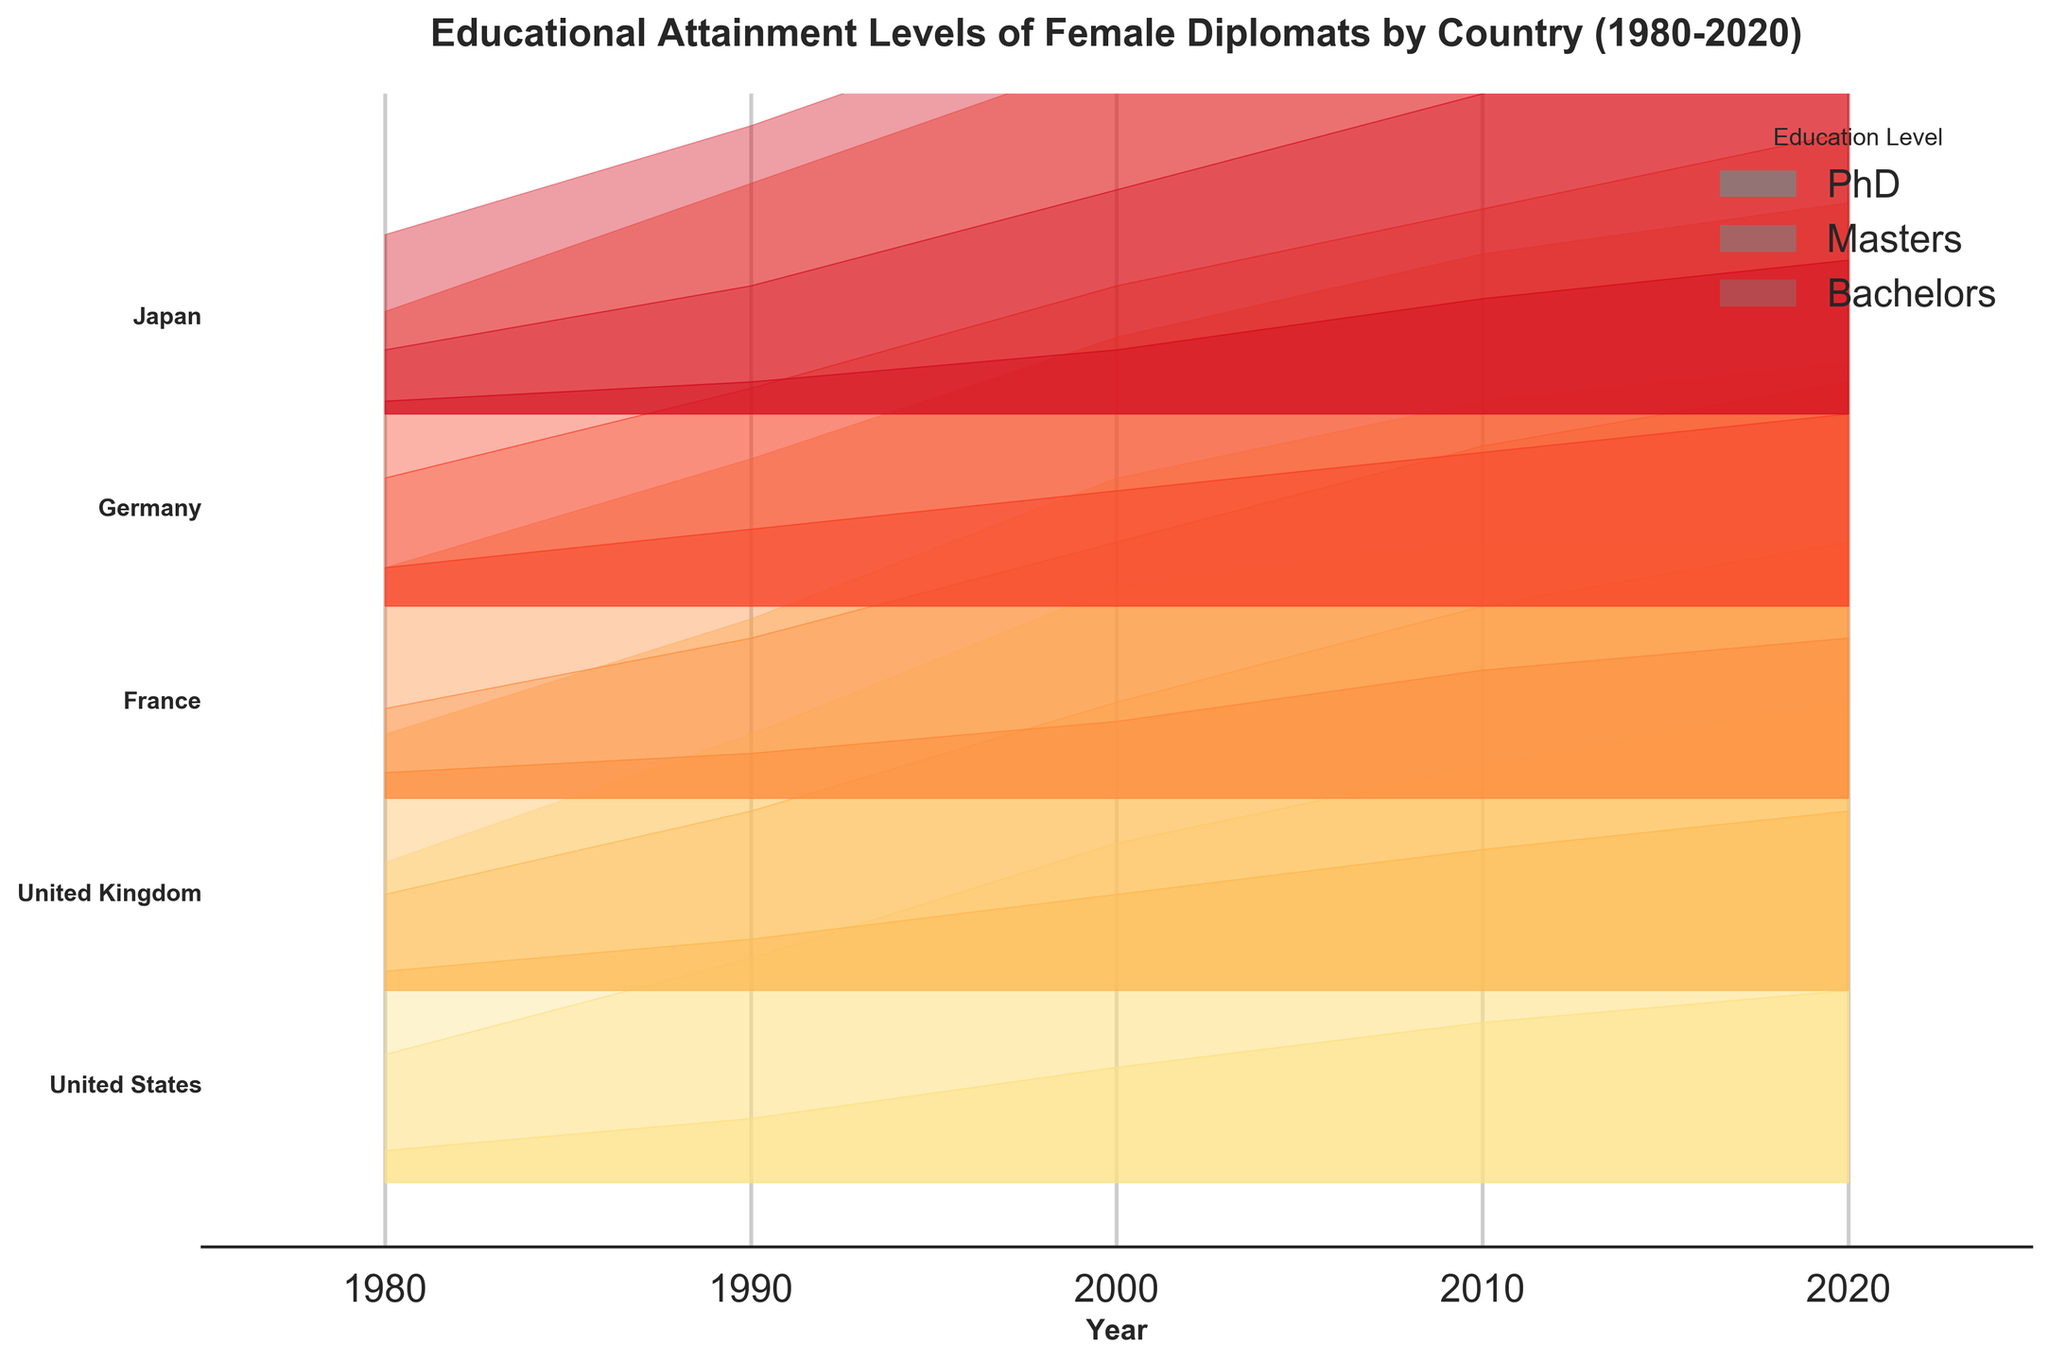Which country had the highest percentage of female diplomats with a PhD in 2020? To find this, look at the highest peak of the PhD area (most opaque gray) for the year 2020 across all countries.
Answer: Germany What is the trend in educational attainment among female diplomats in the United States from 1980 to 2020? Track the changes in the layers (PhD, Masters, Bachelors) over time. Notice that the PhD percentage has increased consistently, while Masters has also shown growth. Bachelors peaked in 2000 and then decreased.
Answer: PhD and Masters increased, Bachelors peaked and then decreased Which country showed the most significant increase in the percentage of female diplomats with a Master's degree from 1980 to 2020? Compare the difference in the Master's layer (middle shade of gray) between 1980 and 2020 for each country.
Answer: United States In 2010, which country had a higher percentage of female diplomats with a Bachelors degree, France or Germany? For 2010, compare the height of the Bachelors layer (lightest gray) for France and Germany.
Answer: Germany How did the educational attainment of female diplomats in Japan change from 1980 to 2020? Observe the ridges for Japan from 1980 to 2020. Notice the percentage increases for each educational level along the timeline.
Answer: All levels increased Which country had the lowest percentage of female diplomats with a Bachelor's degree in 1980? Look for the smallest light gray area in the year 1980 among all countries.
Answer: Japan What does the ridgeline plot tell us about the overall trend in educational attainment for female diplomats over time? Overall, the plot shows an increasing trend in higher educational attainment (PhD and Masters), while the percentage of Bachelors tends to decline over time in some countries.
Answer: Increasing higher degrees, Bachelors decline in some Between 1990 and 2000, which country showed the most notable improvement in PhD attainment among female diplomats? Compare the changes in height for the most opaque (PhD) layer between 1990 and 2000 for each country.
Answer: Germany 